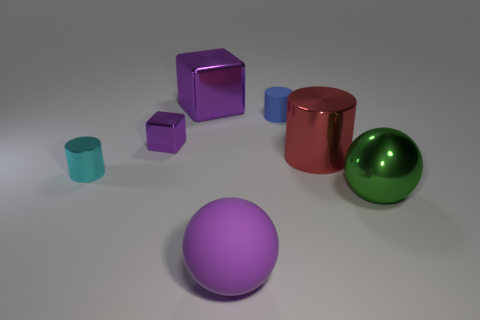What number of large blocks have the same color as the large matte thing?
Your response must be concise. 1. There is a tiny cylinder that is left of the metal object behind the small purple metal object; is there a big purple shiny block that is behind it?
Give a very brief answer. Yes. What is the size of the metal sphere?
Provide a succinct answer. Large. What number of objects are small gray metallic balls or large shiny cubes?
Make the answer very short. 1. There is a large sphere that is the same material as the small blue thing; what color is it?
Make the answer very short. Purple. Is the shape of the purple thing in front of the cyan cylinder the same as  the green thing?
Make the answer very short. Yes. What number of things are either big red shiny things to the right of the large shiny cube or shiny objects to the left of the large green object?
Give a very brief answer. 4. What is the color of the big metal object that is the same shape as the tiny cyan metallic thing?
Give a very brief answer. Red. There is a small matte object; is it the same shape as the cyan shiny thing that is to the left of the green thing?
Your response must be concise. Yes. What material is the blue cylinder?
Ensure brevity in your answer.  Rubber. 